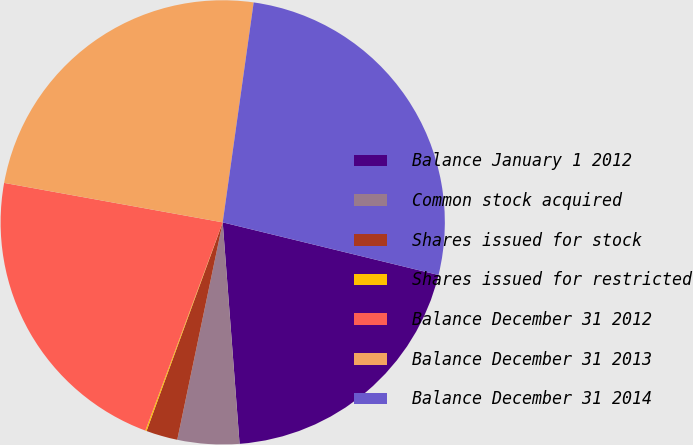Convert chart to OTSL. <chart><loc_0><loc_0><loc_500><loc_500><pie_chart><fcel>Balance January 1 2012<fcel>Common stock acquired<fcel>Shares issued for stock<fcel>Shares issued for restricted<fcel>Balance December 31 2012<fcel>Balance December 31 2013<fcel>Balance December 31 2014<nl><fcel>19.98%<fcel>4.49%<fcel>2.29%<fcel>0.09%<fcel>22.18%<fcel>24.38%<fcel>26.58%<nl></chart> 